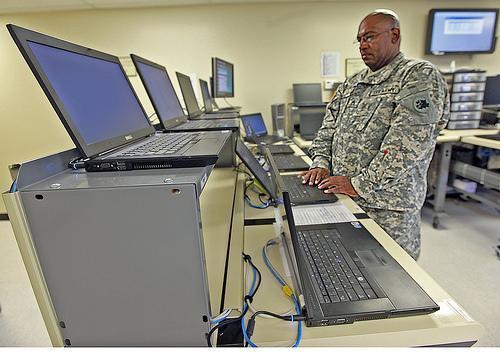How many computers are there?
Give a very brief answer. 10. 